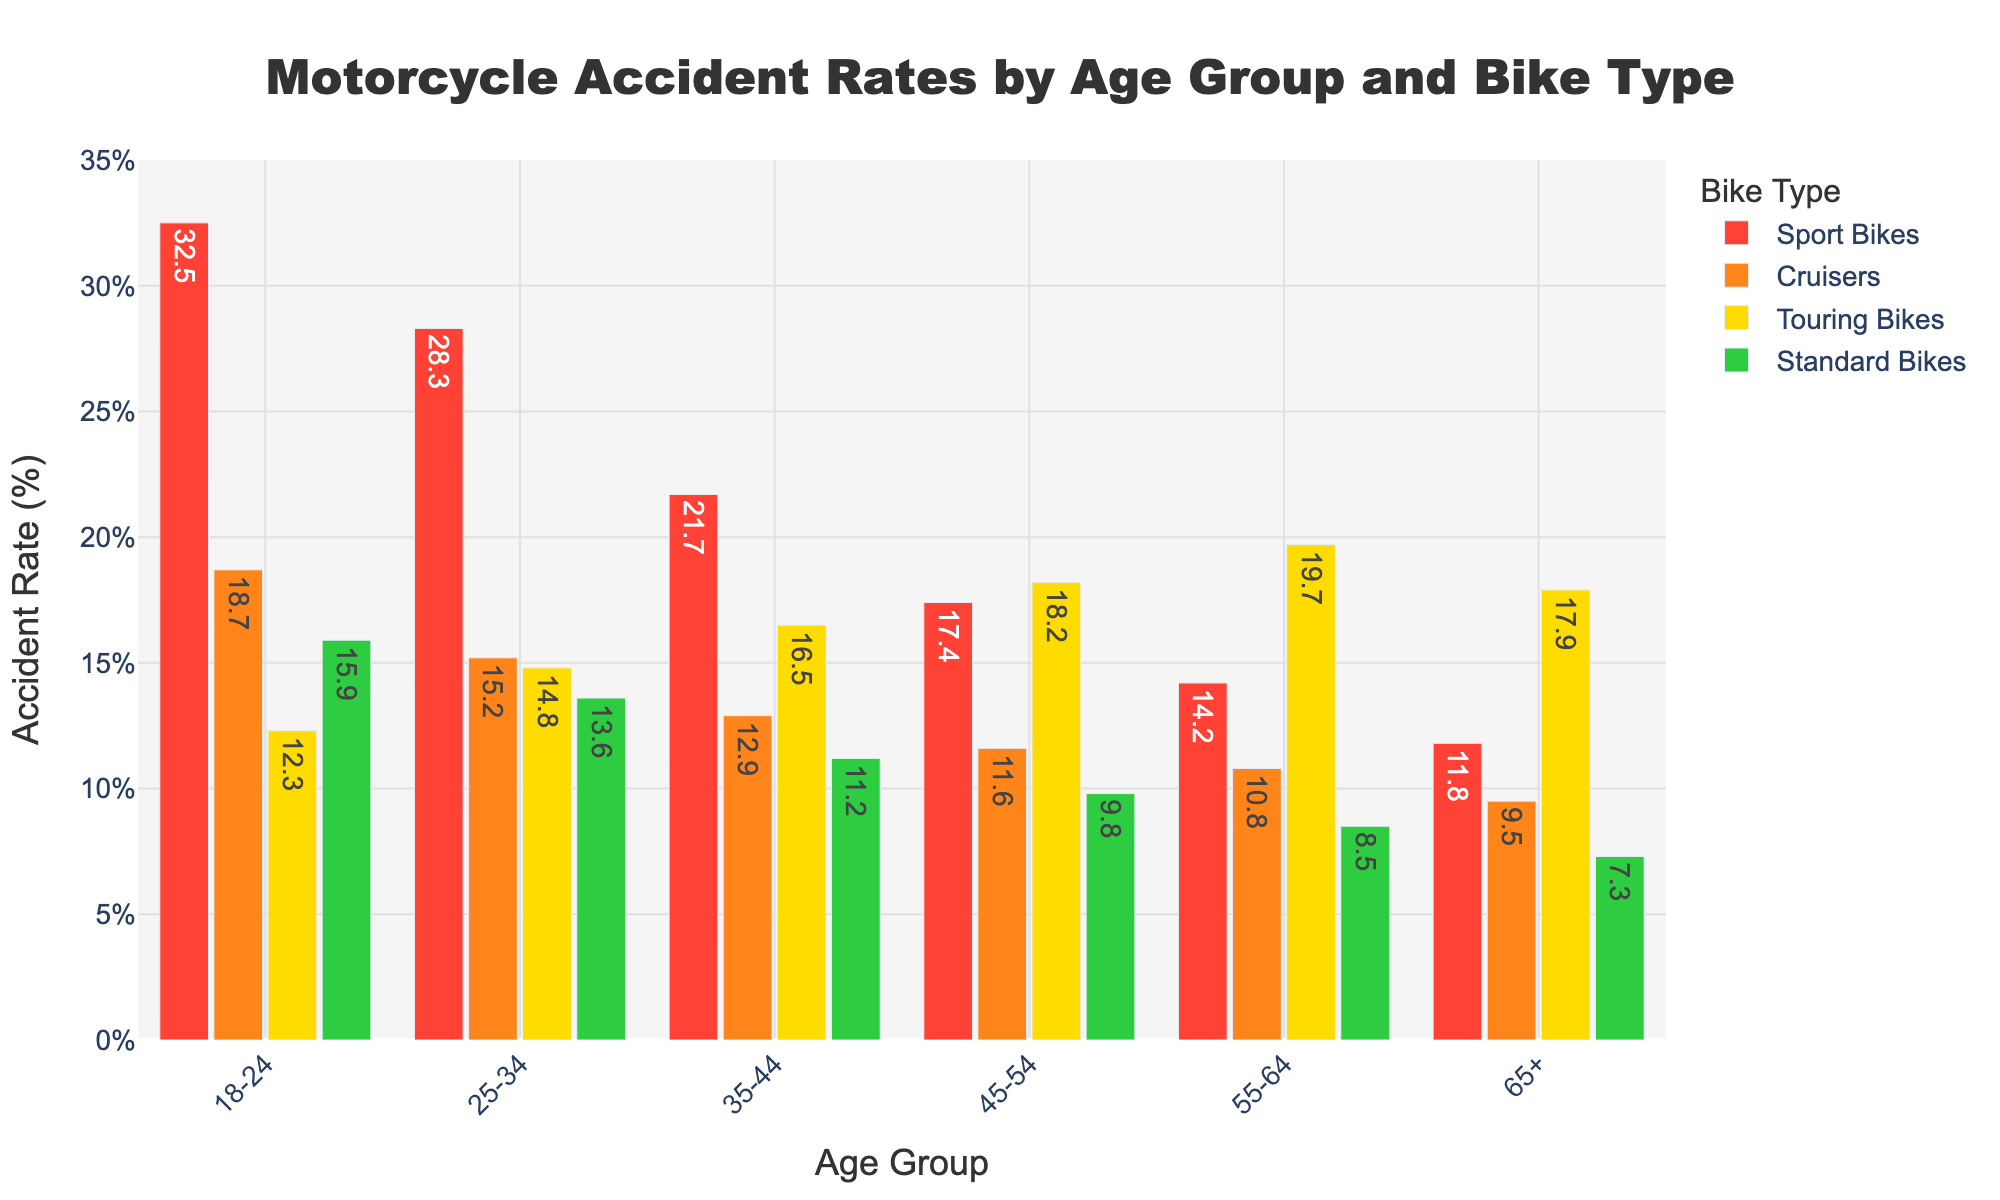Which age group has the highest accident rate for sport bikes? The red bars represent sport bikes. The tallest red bar is for the 18-24 age group, indicating the highest accident rate.
Answer: 18-24 How does the accident rate for cruisers change from the 18-24 age group to the 25-34 age group? The orange bars represent cruisers. The height of the orange bar for the 18-24 age group is higher than for the 25-34 age group, indicating a decrease.
Answer: Decreases Among the 45-54 age group, which bike type has the lowest accident rate? For the 45-54 age group, compare the heights of all the bars. The green bar, representing standard bikes, is the shortest.
Answer: Standard Bikes What's the difference in accident rates between touring bikes and standard bikes in the 55-64 age group? The yellow bar for touring bikes in the 55-64 age group is at 19.7%, and the green bar for standard bikes is at 8.5%. The difference is 19.7 - 8.5.
Answer: 11.2% Which bike type shows the most significant decrease in accident rate from the 18-24 age group to the 65+ age group? Compare the differences in the bar heights for each bike type from 18-24 to 65+. The red bars, representing sport bikes, show the most significant decrease from 32.5% to 11.8%.
Answer: Sport Bikes What is the combined accident rate for all bike types in the 25-34 age group? Add the accident rates for all bike types in the 25-34 age group: 28.3 (Sport Bikes) + 15.2 (Cruisers) + 14.8 (Touring Bikes) + 13.6 (Standard Bikes).
Answer: 71.9% Which bike type has a nearly uniform accident rate across all age groups? Touring bikes (yellow bars) have relatively uniform heights across the age groups compared to other bike types.
Answer: Touring Bikes In the 35-44 age group, which two bike types have the closest accident rates? For the 35-44 age group, the heights of the yellow and orange bars (representing touring bikes and cruisers) are closest, with values of 16.5% and 12.9%, respectively.
Answer: Cruisers and Touring Bikes What's the average accident rate for cruisers across all age groups? Add the accident rates for cruisers across all age groups and divide by the number of age groups: (18.7 + 15.2 + 12.9 + 11.6 + 10.8 + 9.5) / 6.
Answer: 13.12% What is the trend for standard bike accident rates as the age group increases? Examine the green bars for each successive age group. The heights decrease progressively, indicating a downward trend in accident rates for standard bikes as age increases.
Answer: Decreasing 